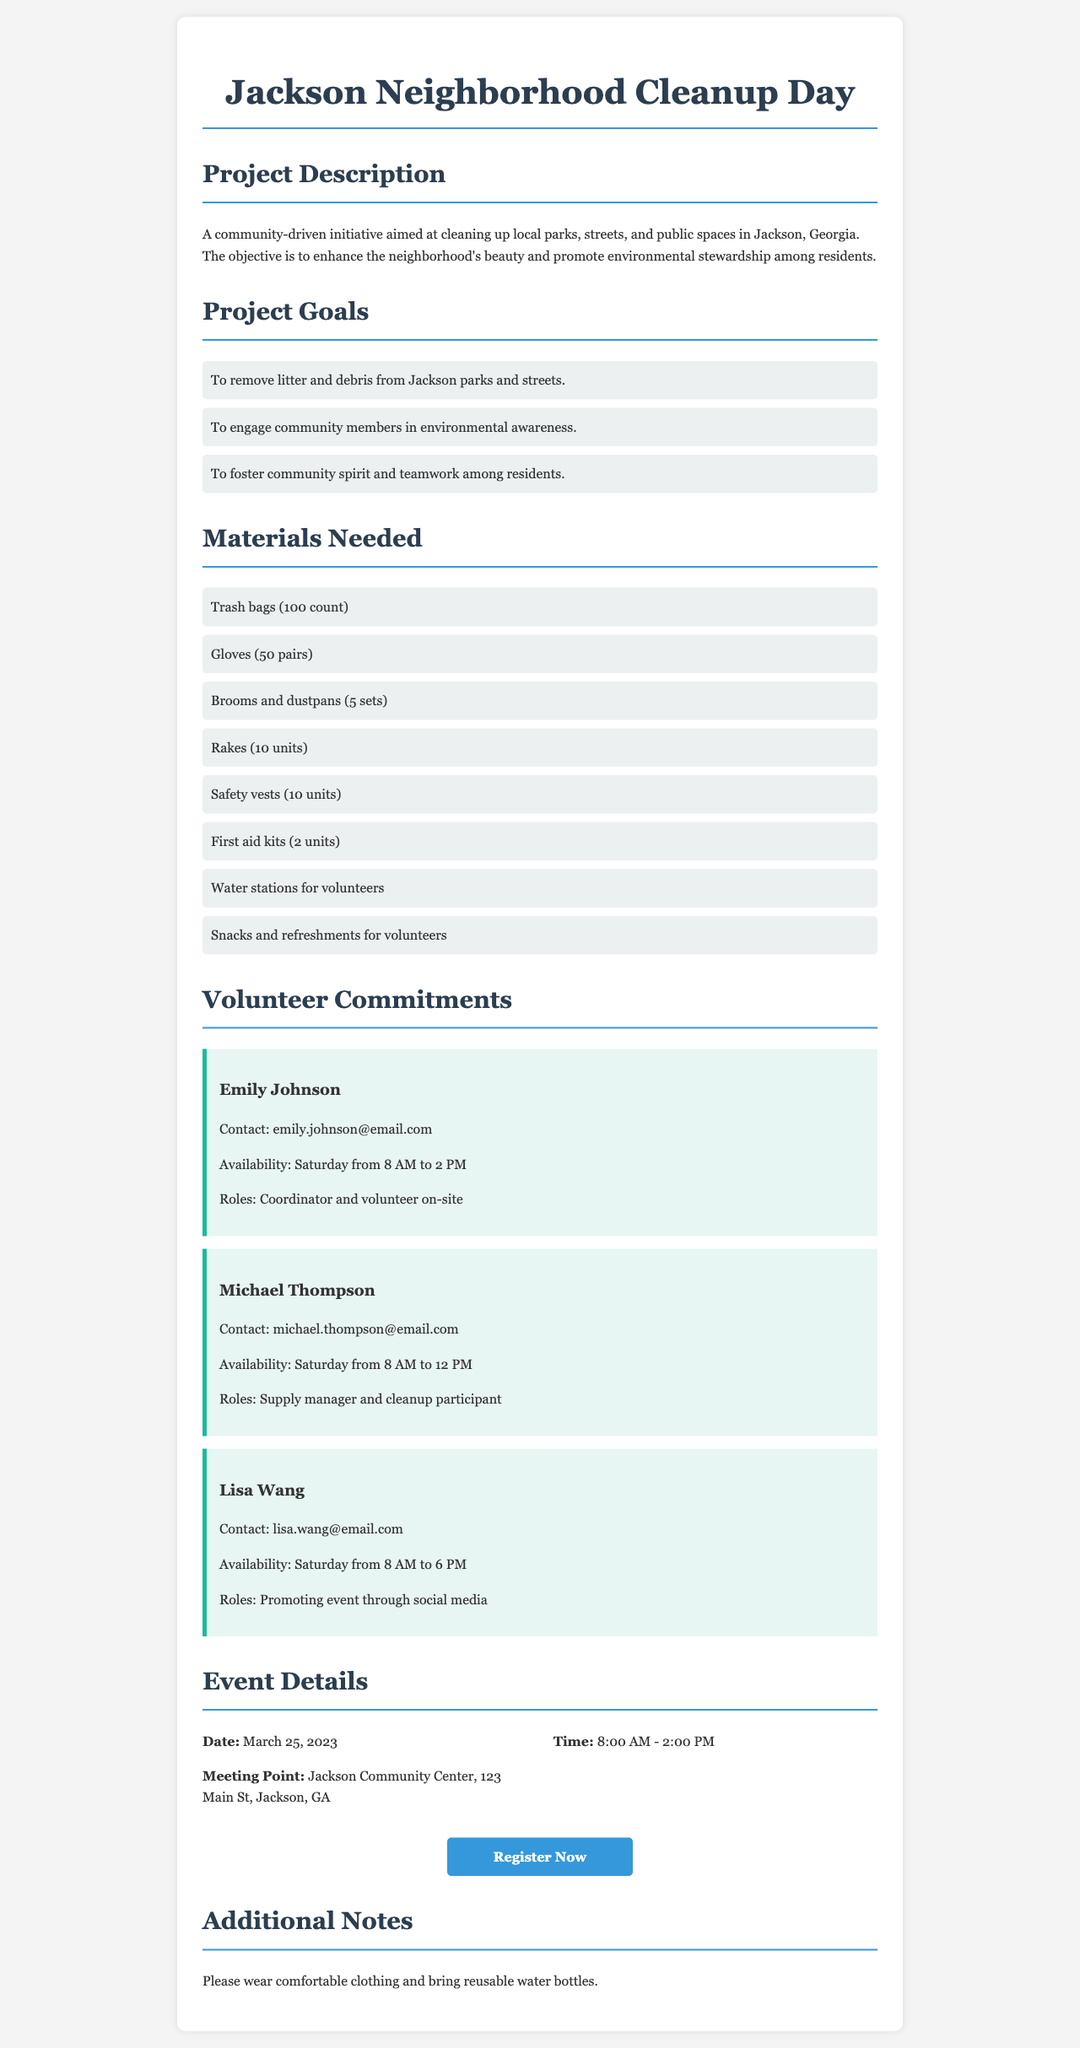What is the project title? The project title is the main heading of the document and identifies the purpose of the initiative.
Answer: Jackson Neighborhood Cleanup Day What is the date of the event? The date of the event is provided in the event details section of the document.
Answer: March 25, 2023 How many pairs of gloves are needed? The number of glove pairs needed is listed under the materials section of the document.
Answer: 50 pairs Who is the supply manager? The supply manager is mentioned in the volunteer commitments section along with their contact information and role.
Answer: Michael Thompson What time does the event start? The start time is included in the event details of the document.
Answer: 8:00 AM What is one goal of the project? The goals are specified in the project goals section, and this question asks for a specific example.
Answer: To remove litter and debris from Jackson parks and streets How many trash bags are required for the cleanup? The required item quantity is explicitly stated in the materials needed section of the document.
Answer: 100 count What role does Lisa Wang have? This question asks about the specific responsibilities assigned to the volunteer mentioned in the document.
Answer: Promoting event through social media What is the meeting point for the event? The meeting point is indicated in the event details section and helps participants know where to gather.
Answer: Jackson Community Center, 123 Main St, Jackson, GA 